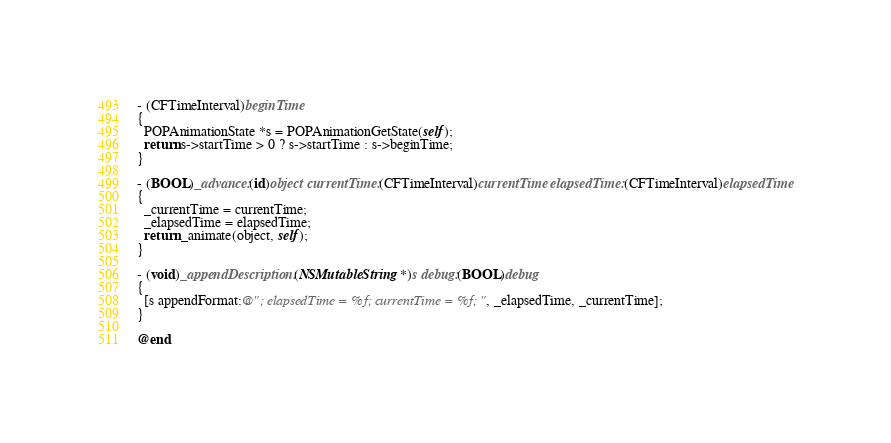Convert code to text. <code><loc_0><loc_0><loc_500><loc_500><_ObjectiveC_>
- (CFTimeInterval)beginTime
{
  POPAnimationState *s = POPAnimationGetState(self);
  return s->startTime > 0 ? s->startTime : s->beginTime;
}

- (BOOL)_advance:(id)object currentTime:(CFTimeInterval)currentTime elapsedTime:(CFTimeInterval)elapsedTime
{
  _currentTime = currentTime;
  _elapsedTime = elapsedTime;
  return _animate(object, self);
}

- (void)_appendDescription:(NSMutableString *)s debug:(BOOL)debug
{
  [s appendFormat:@"; elapsedTime = %f; currentTime = %f;", _elapsedTime, _currentTime];
}

@end
</code> 